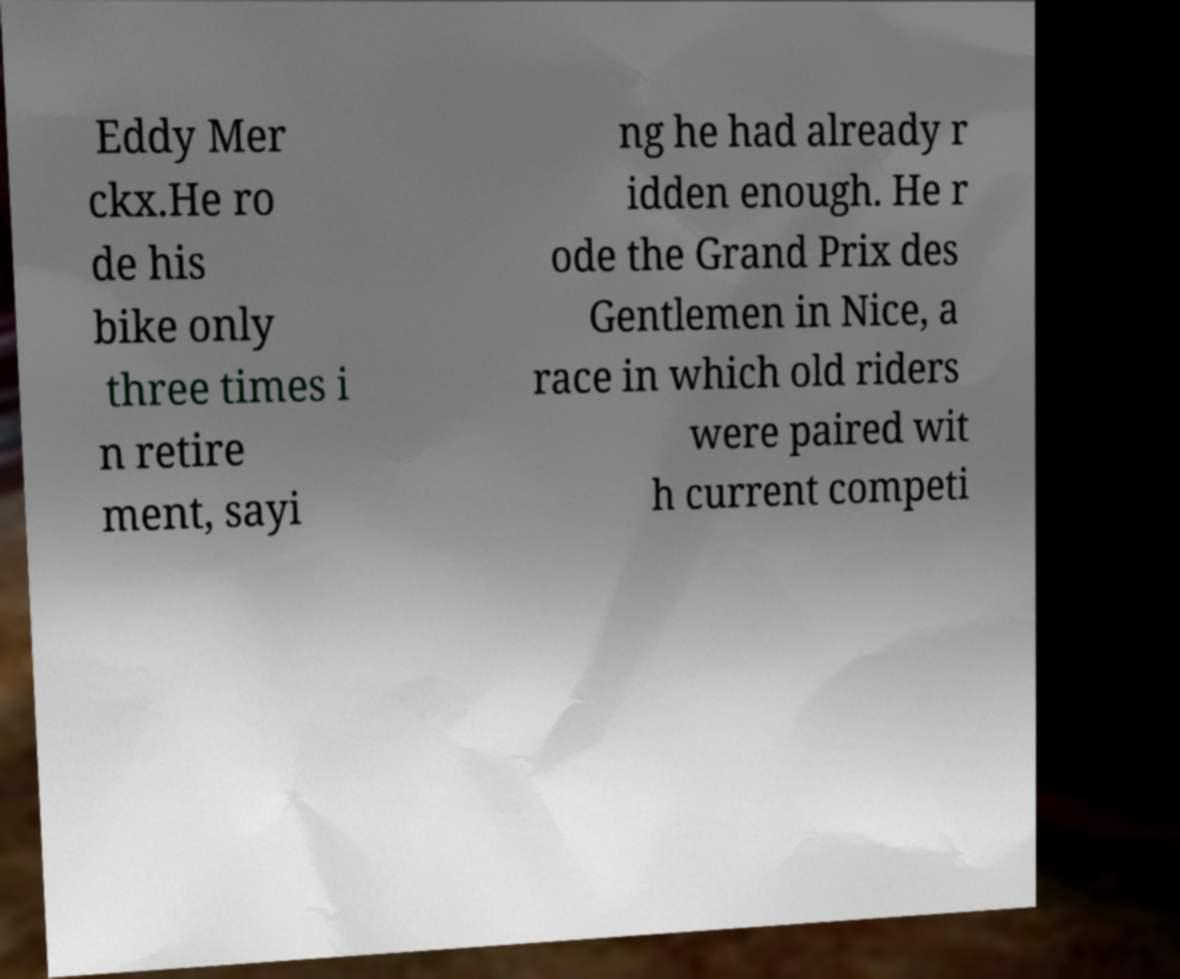For documentation purposes, I need the text within this image transcribed. Could you provide that? Eddy Mer ckx.He ro de his bike only three times i n retire ment, sayi ng he had already r idden enough. He r ode the Grand Prix des Gentlemen in Nice, a race in which old riders were paired wit h current competi 